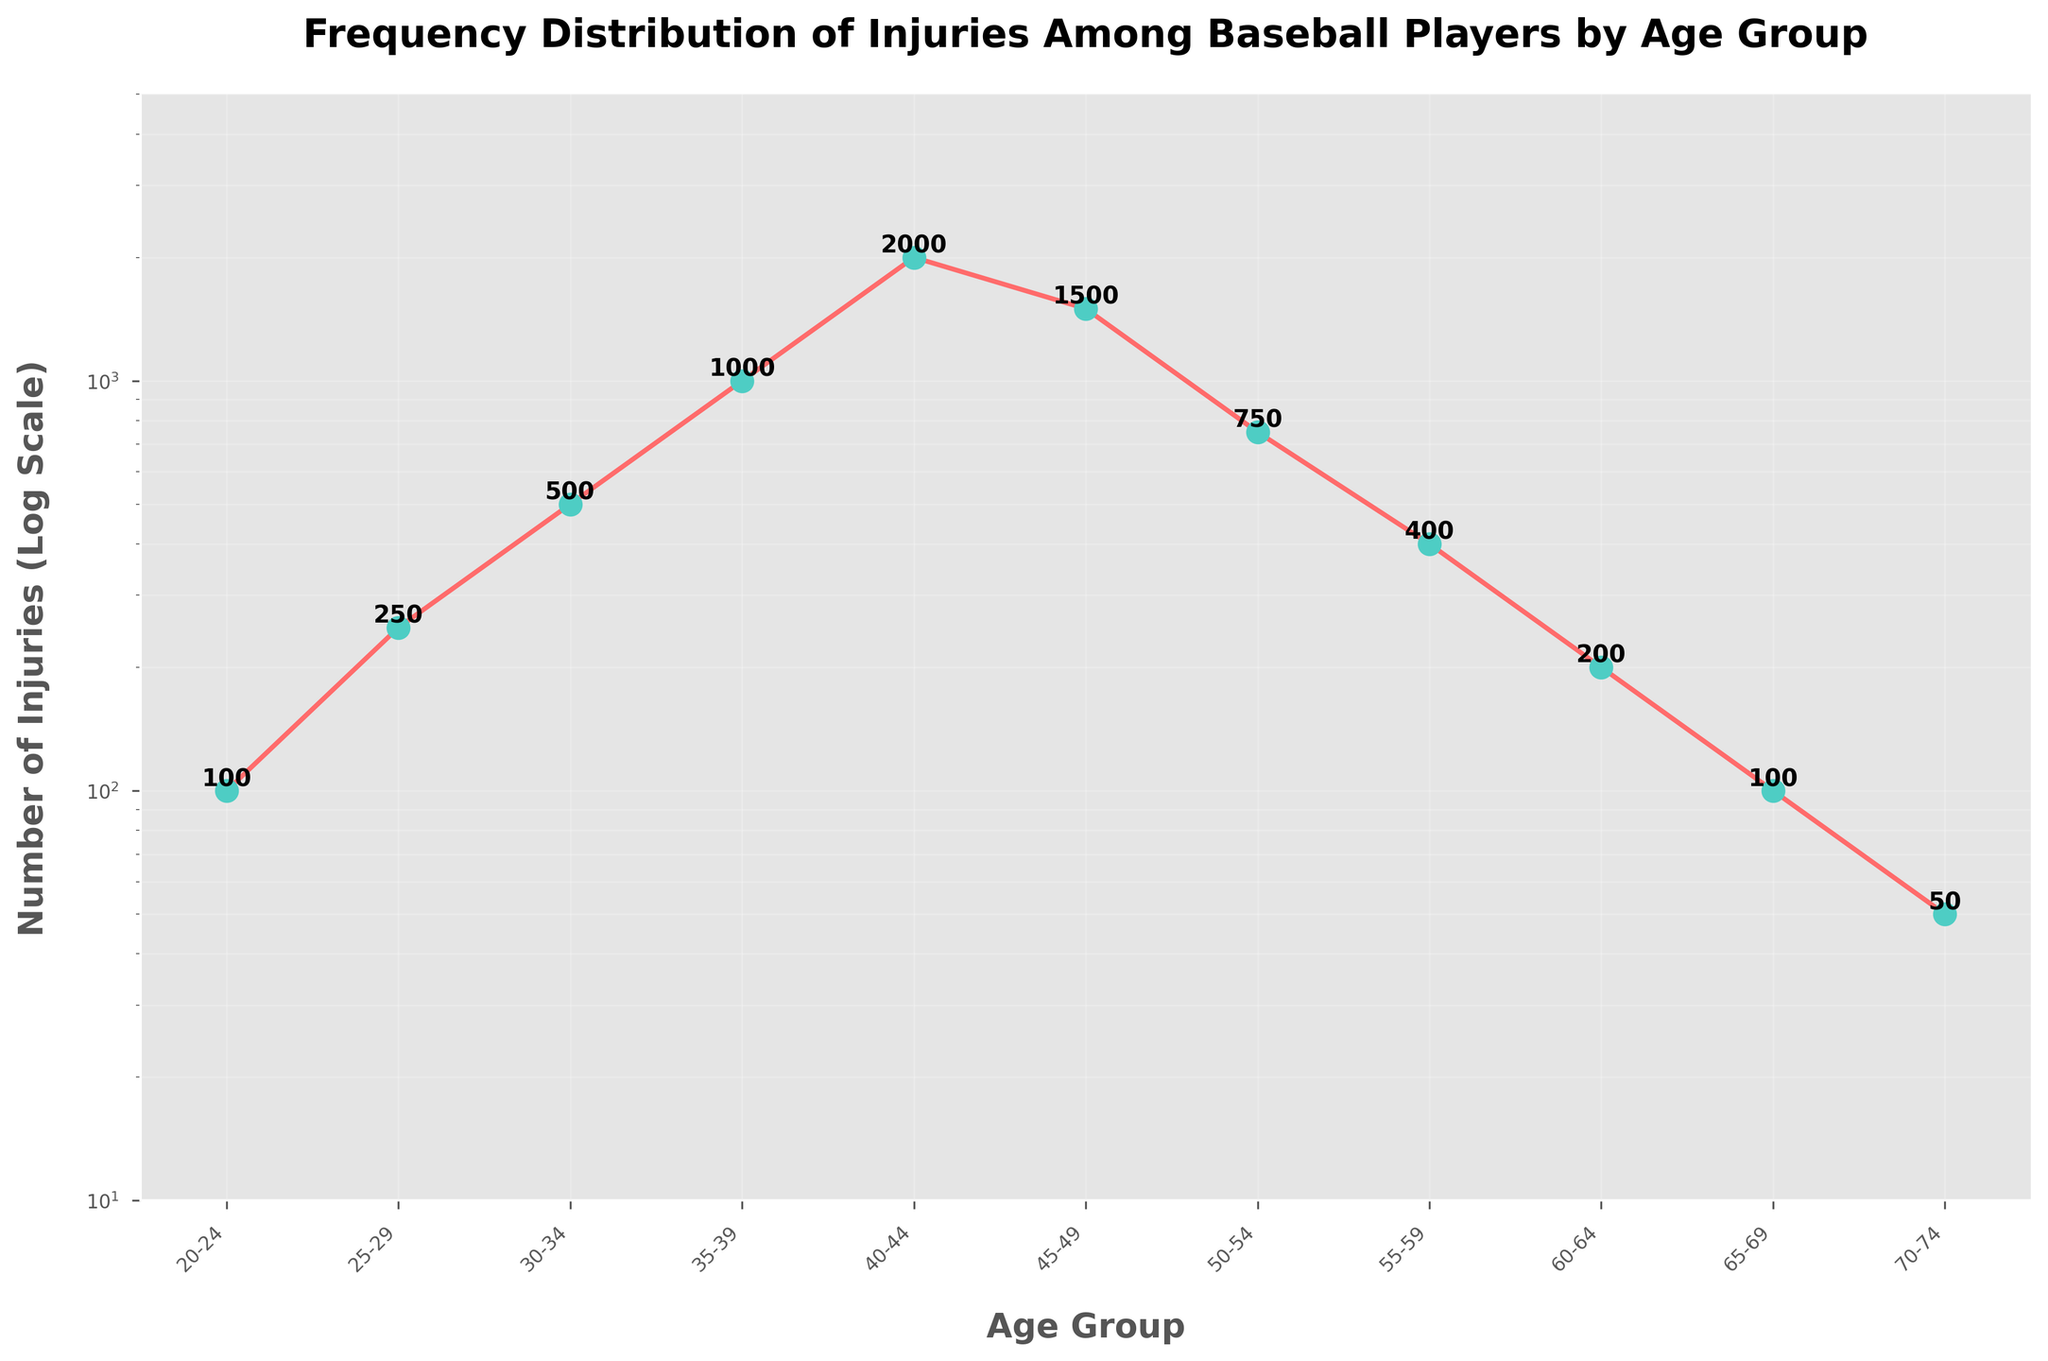What is the title of the figure? The title is usually found at the top of the figure and describes what the figure is about.
Answer: Frequency Distribution of Injuries Among Baseball Players by Age Group How many age groups are included in the figure? Count the number of data points or x-ticks labeled with age groups in the plot.
Answer: 11 Which age group has the highest number of injuries? Look for the data point that is the highest on the y-axis (log scale) and check its corresponding x-tick label.
Answer: 40-44 Is the number of injuries for the age group 45-49 greater or less than for the age group 35-39? Compare the y-values (height in the plot) for the age groups 45-49 and 35-39. Since the y-axis is a log scale, visually check whether the data point at 45-49 is higher or lower than at 35-39.
Answer: Less What is the general trend observed in the frequency distribution of injuries as age increases? Observe the shape of the line connecting the data points; note if it generally increases, decreases, stays constant, or follows another pattern.
Answer: Increases initially, then decreases after age 40-44 What are the number of injuries for the youngest and oldest age groups? Find the y-values corresponding to the youngest (20-24) and oldest (70-74) age groups.
Answer: 100 for 20-24 and 50 for 70-74 Which age group has the steepest increase in the number of injuries from the previous age group? Identify the pair of consecutive age groups where the line connecting them has the steepest upward slope, or largest difference in the log scale y-values.
Answer: 35-39 to 40-44 How do the number of injuries for the age group 30-34 compare to the age group 50-54? Compare the y-values (heights of the data points) for the age groups 30-34 and 50-54.
Answer: 30-34 has more At what age group does the number of injuries start to decrease after initially increasing? Look for the point where the upward trend in the line plot changes to a downward trend.
Answer: After 40-44 What is the difference in the number of injuries between the age groups 25-29 and 60-64? Subtract the number of injuries for the age group 60-64 from the number of injuries for 25-29.
Answer: 250 - 200 = 50 